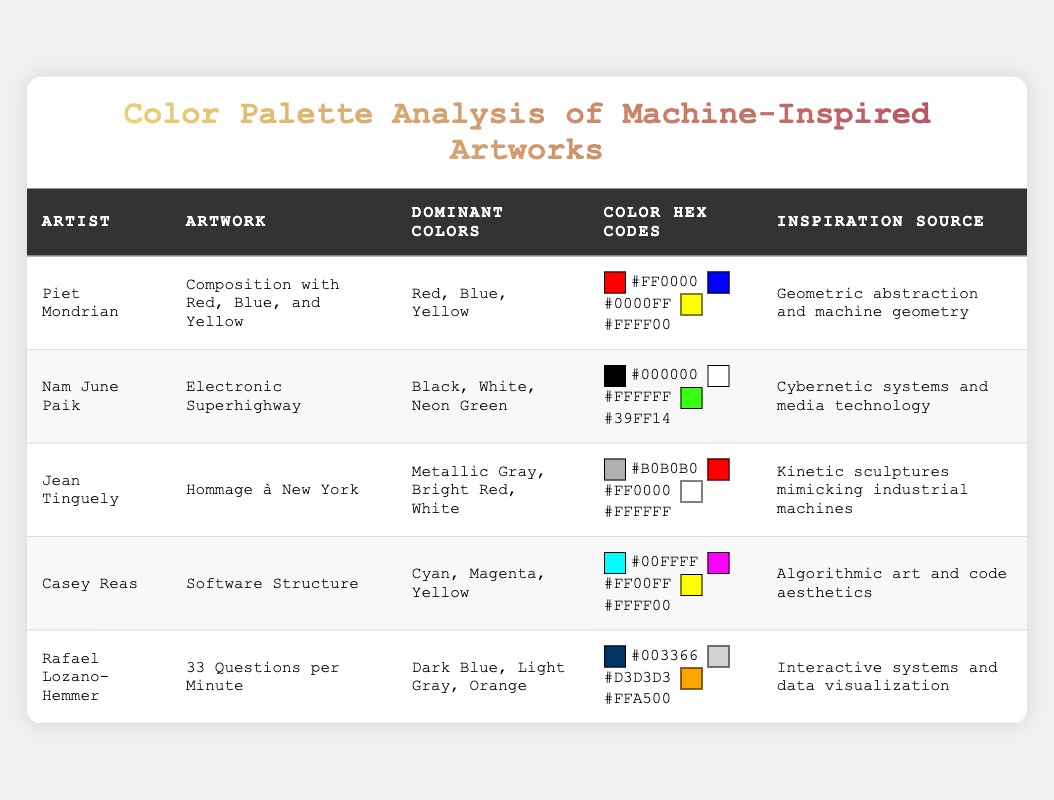What are the dominant colors used in Nam June Paik's artwork? The table lists the dominant colors for each artwork. For Nam June Paik's "Electronic Superhighway," the dominant colors are Black, White, and Neon Green.
Answer: Black, White, Neon Green Which artist used a color palette that includes metallic gray? I check the table for artists who have metallic gray in their dominant colors. Jean Tinguely's "Hommage à New York" includes Metallic Gray in its palette.
Answer: Jean Tinguely Is there an artwork inspired by cybernetic systems and media technology? I look for the inspiration sources listed in the table. Nam June Paik's "Electronic Superhighway" is explicitly noted as being inspired by cybernetic systems and media technology.
Answer: Yes What is the average number of dominant colors used in the artworks displayed in the table? Calculating the number of dominant colors in each artwork, we have 3 (Mondrian) + 3 (Paik) + 3 (Tinguely) + 3 (Reas) + 3 (Lozano-Hemmer) for a total of 15 dominant colors. There are 5 artworks, so the average is 15 divided by 5, which equals 3.
Answer: 3 Which artwork has the most vibrant dominant colors? I identify vibrant colors such as Neon Green from Nam June Paik's "Electronic Superhighway" and Bright Red from Jean Tinguely's "Hommage à New York." Comparing all artworks, "Electronic Superhighway" is noted for its use of Neon Green, making it highly vibrant in the color palette.
Answer: Electronic Superhighway How many artworks predominantly feature the color red? I scan the table for artworks that prominently include red. I find Mondrian's "Composition with Red, Blue, and Yellow," Tinguely's "Hommage à New York," and Reas's "Software Structure." Thus, there are three artworks featuring red as a dominant color.
Answer: 3 Which artist(s) have artworks that incorporate both cyan and magenta in their color palettes? I check the dominant colors in the table and see that Casey Reas's “Software Structure” includes Cyan and Magenta in its palette. So, he is the artist who uses both colors.
Answer: Casey Reas Is there any artwork in the table that combines both black and white as dominant colors? I examine the dominant colors mentioned for each artwork. Nam June Paik's "Electronic Superhighway" includes both Black and White in its notable colors.
Answer: Yes 